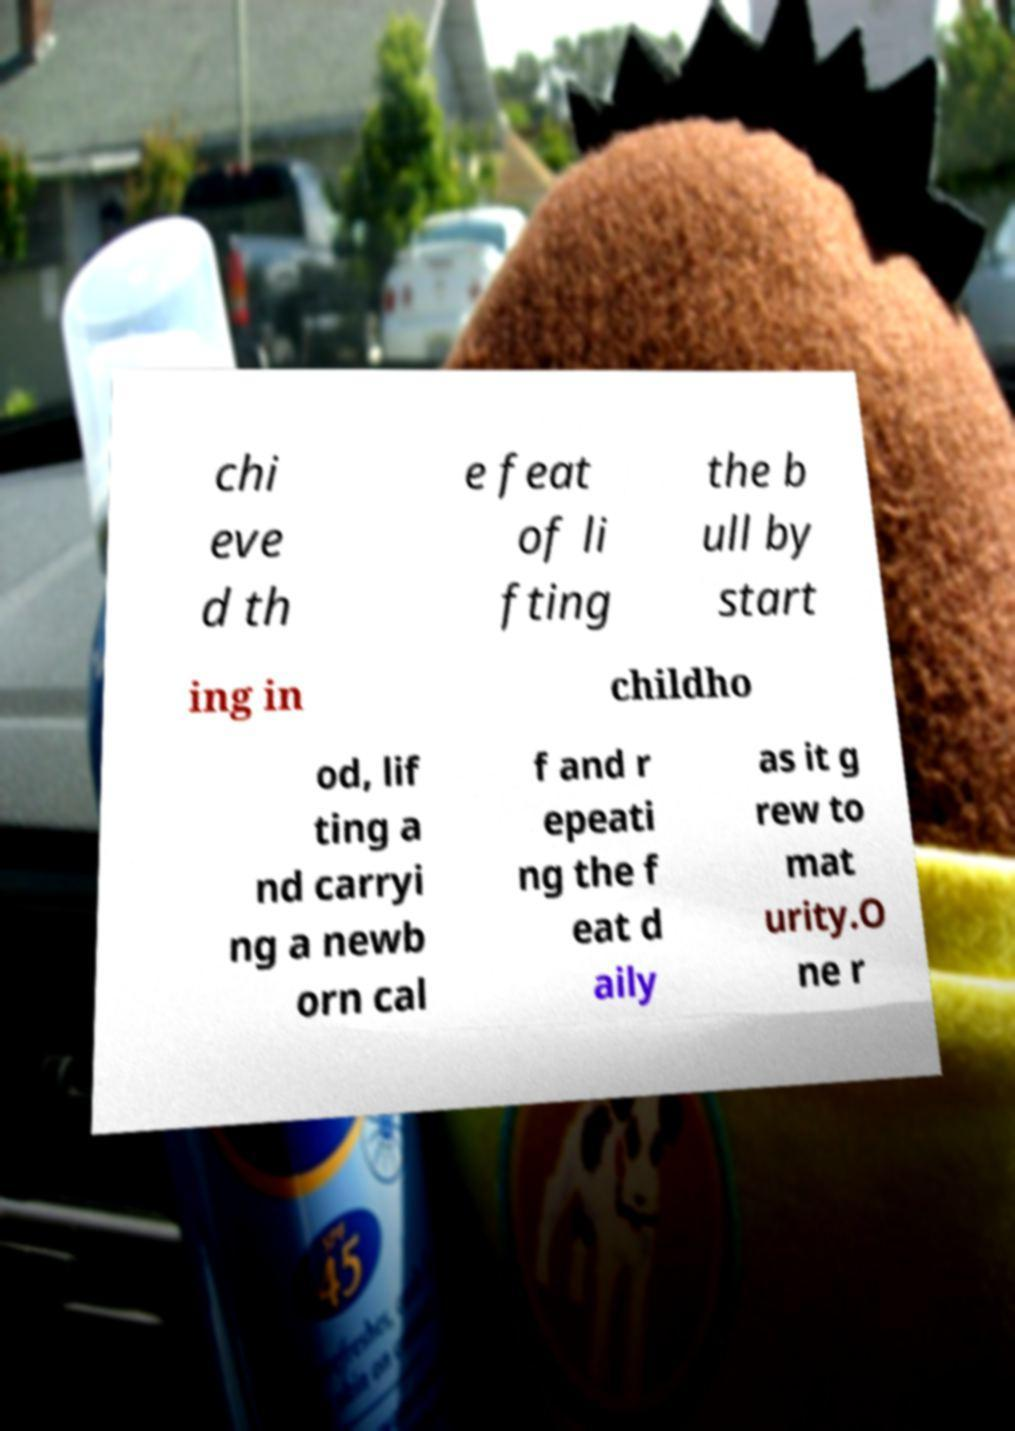I need the written content from this picture converted into text. Can you do that? chi eve d th e feat of li fting the b ull by start ing in childho od, lif ting a nd carryi ng a newb orn cal f and r epeati ng the f eat d aily as it g rew to mat urity.O ne r 